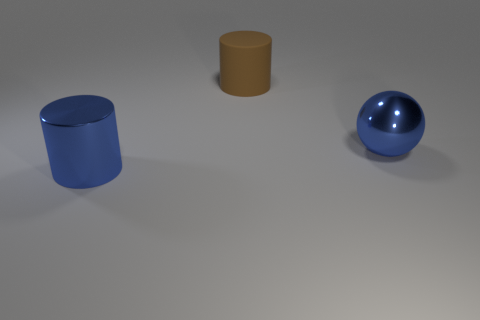There is a ball that is made of the same material as the big blue cylinder; what size is it?
Provide a succinct answer. Large. Is the number of metallic objects to the left of the large rubber cylinder greater than the number of large gray rubber cubes?
Offer a very short reply. Yes. The thing that is to the right of the cylinder that is right of the metal thing that is to the left of the brown cylinder is made of what material?
Offer a very short reply. Metal. Is the material of the big blue cylinder the same as the thing that is behind the blue metallic sphere?
Your answer should be compact. No. There is another blue thing that is the same shape as the matte object; what is its material?
Your response must be concise. Metal. Is there any other thing that is made of the same material as the big brown cylinder?
Your answer should be very brief. No. Are there more big metallic objects that are to the right of the rubber object than large objects in front of the blue metallic cylinder?
Your response must be concise. Yes. What is the shape of the big blue thing that is made of the same material as the blue ball?
Your answer should be very brief. Cylinder. What number of other objects are the same shape as the brown object?
Give a very brief answer. 1. There is a big thing that is to the right of the brown rubber cylinder; what is its shape?
Ensure brevity in your answer.  Sphere. 